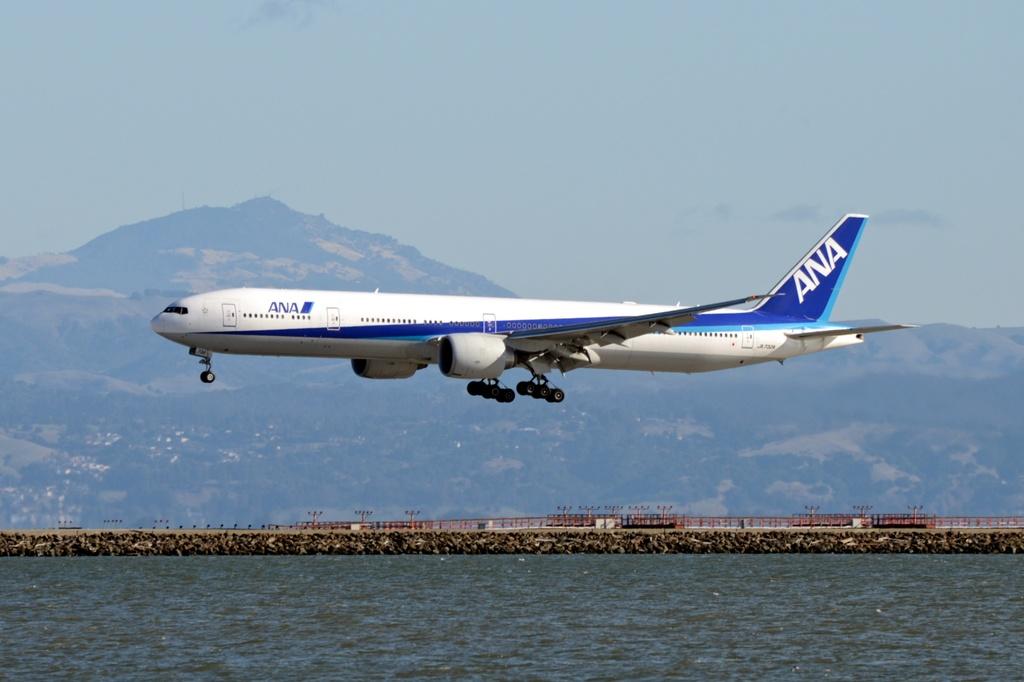What airline is this?
Your answer should be very brief. Ana. 